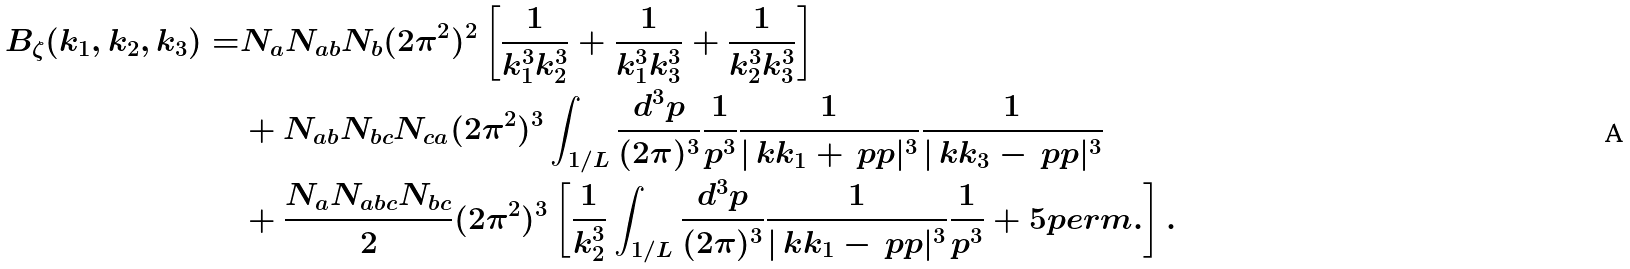<formula> <loc_0><loc_0><loc_500><loc_500>B _ { \zeta } ( k _ { 1 } , k _ { 2 } , k _ { 3 } ) = & N _ { a } N _ { a b } N _ { b } ( 2 \pi ^ { 2 } ) ^ { 2 } \left [ \frac { 1 } { k _ { 1 } ^ { 3 } k _ { 2 } ^ { 3 } } + \frac { 1 } { k _ { 1 } ^ { 3 } k _ { 3 } ^ { 3 } } + \frac { 1 } { k _ { 2 } ^ { 3 } k _ { 3 } ^ { 3 } } \right ] \\ & + N _ { a b } N _ { b c } N _ { c a } ( 2 \pi ^ { 2 } ) ^ { 3 } \int _ { 1 / L } \frac { d ^ { 3 } p } { ( 2 \pi ) ^ { 3 } } \frac { 1 } { p ^ { 3 } } \frac { 1 } { | \ k k _ { 1 } + \ p p | ^ { 3 } } \frac { 1 } { | \ k k _ { 3 } - \ p p | ^ { 3 } } \\ & + \frac { N _ { a } N _ { a b c } N _ { b c } } { 2 } ( 2 \pi ^ { 2 } ) ^ { 3 } \left [ \frac { 1 } { k _ { 2 } ^ { 3 } } \int _ { 1 / L } \frac { d ^ { 3 } p } { ( 2 \pi ) ^ { 3 } } \frac { 1 } { | \ k k _ { 1 } - \ p p | ^ { 3 } } \frac { 1 } { p ^ { 3 } } + 5 p e r m . \right ] .</formula> 